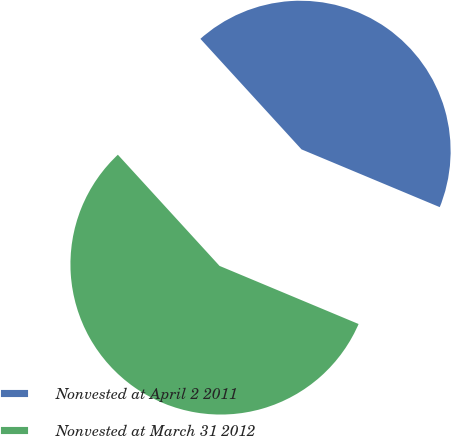<chart> <loc_0><loc_0><loc_500><loc_500><pie_chart><fcel>Nonvested at April 2 2011<fcel>Nonvested at March 31 2012<nl><fcel>43.09%<fcel>56.91%<nl></chart> 